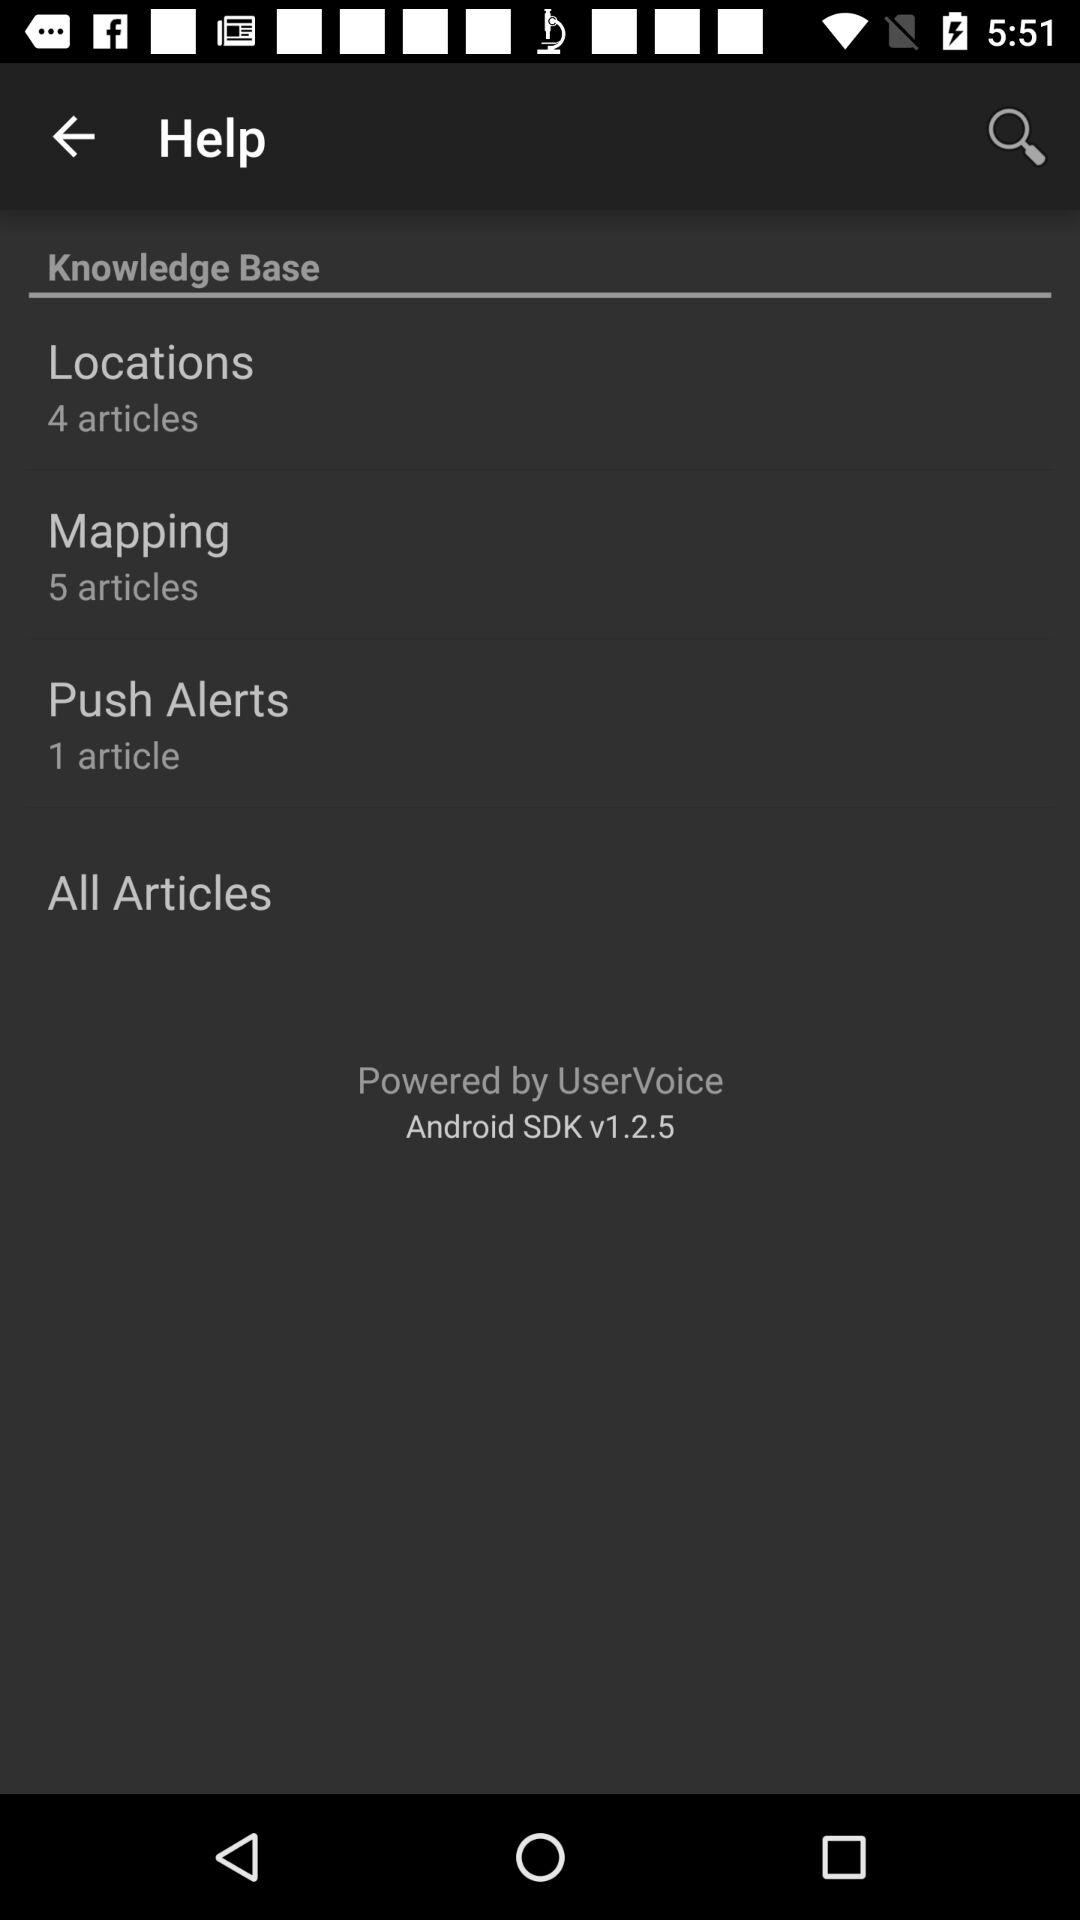How many articles are there in "Locations"? There are 4 articles in "Locations". 